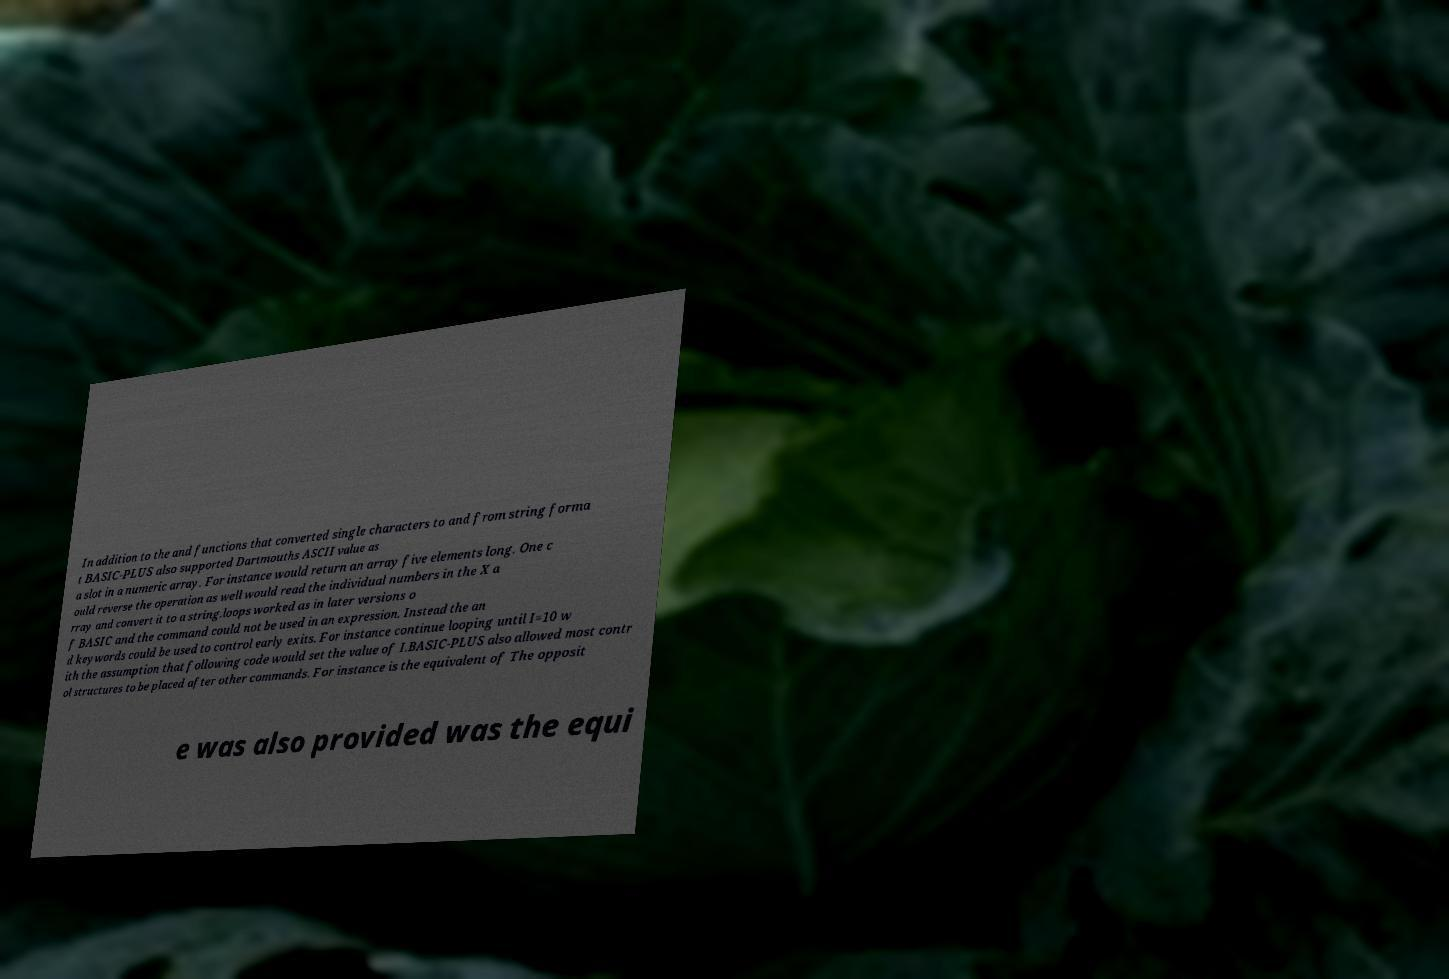Can you read and provide the text displayed in the image?This photo seems to have some interesting text. Can you extract and type it out for me? In addition to the and functions that converted single characters to and from string forma t BASIC-PLUS also supported Dartmouths ASCII value as a slot in a numeric array. For instance would return an array five elements long. One c ould reverse the operation as well would read the individual numbers in the X a rray and convert it to a string.loops worked as in later versions o f BASIC and the command could not be used in an expression. Instead the an d keywords could be used to control early exits. For instance continue looping until I=10 w ith the assumption that following code would set the value of I.BASIC-PLUS also allowed most contr ol structures to be placed after other commands. For instance is the equivalent of The opposit e was also provided was the equi 